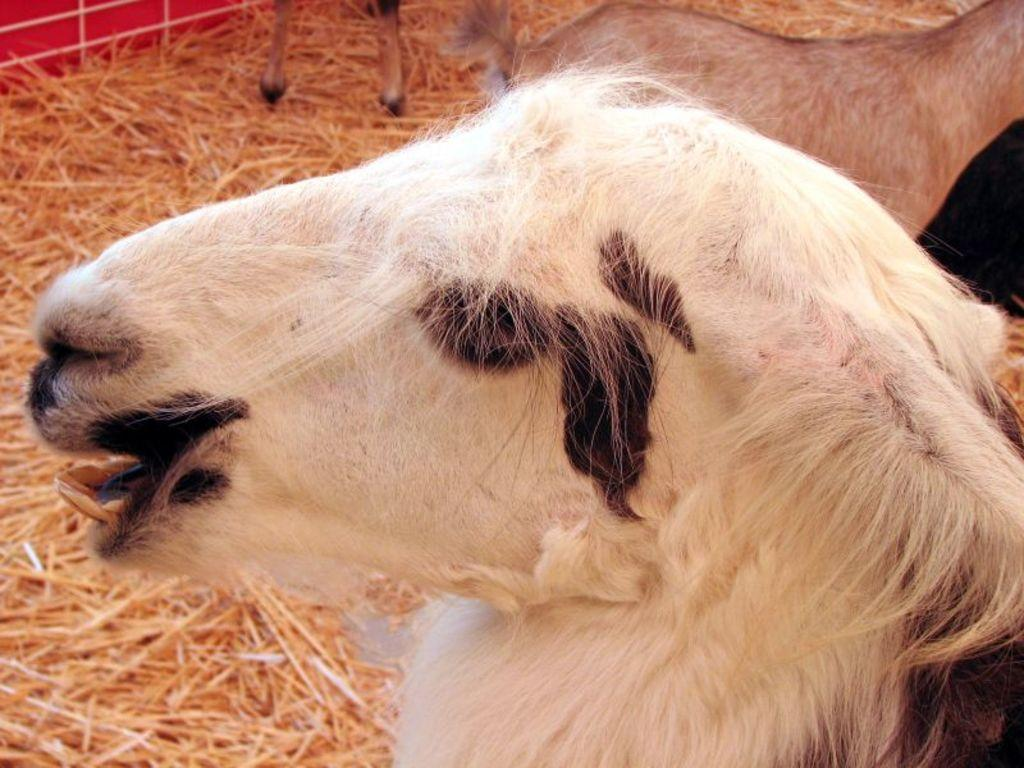What type of animal is in the image? The animal in the image is in black and white color. What can be seen in the background of the image? The background of the image includes dried grass. What is the color of the dried grass? The dried grass is in brown color. What type of magic is being performed by the animal in the image? There is no indication of magic or any performance in the image; it simply features an animal in black and white color with a brown dried grass background. 